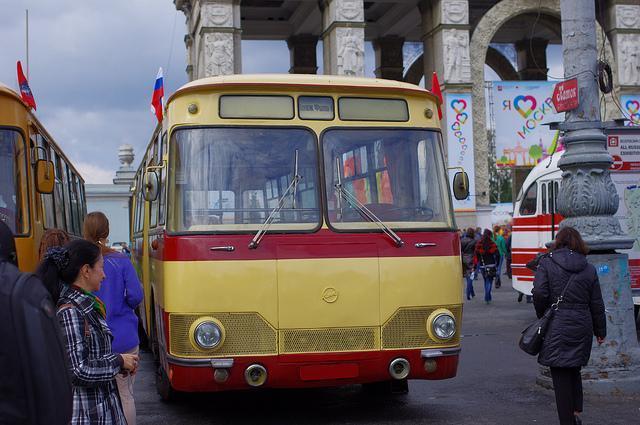How many people are there?
Give a very brief answer. 4. How many buses are in the picture?
Give a very brief answer. 2. How many horses have white on them?
Give a very brief answer. 0. 